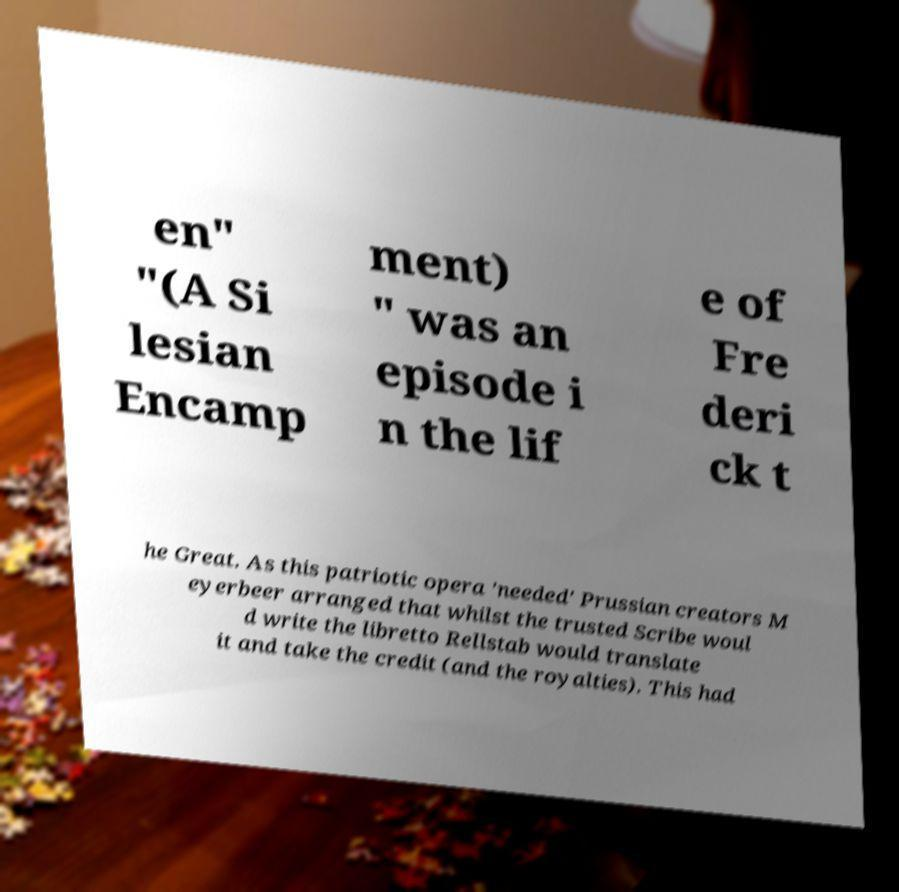Can you accurately transcribe the text from the provided image for me? en" "(A Si lesian Encamp ment) " was an episode i n the lif e of Fre deri ck t he Great. As this patriotic opera 'needed' Prussian creators M eyerbeer arranged that whilst the trusted Scribe woul d write the libretto Rellstab would translate it and take the credit (and the royalties). This had 